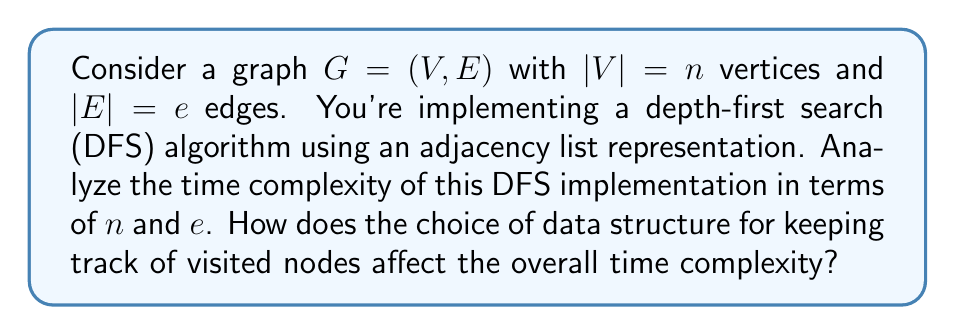Teach me how to tackle this problem. Let's break down the analysis step-by-step:

1. Initialization:
   - Creating an adjacency list: $O(n + e)$
   - Initializing a data structure to keep track of visited nodes: $O(n)$

2. DFS traversal:
   - Each vertex is processed once: $O(n)$
   - For each vertex, we iterate through its adjacent vertices:
     $$\sum_{v \in V} \text{degree}(v) = 2e$$
     This sum is $2e$ because each edge contributes to the degree of two vertices.

3. Visiting a node:
   The time complexity of marking a node as visited depends on the data structure used:
   - Array: $O(1)$
   - Hash set: $O(1)$ average case, $O(n)$ worst case
   - Bit vector: $O(1)$

4. Total time complexity:
   $$T(n, e) = O(n + e) + O(n) + O(n) + O(2e) * O(1) = O(n + e)$$

The choice of data structure for keeping track of visited nodes doesn't significantly affect the overall time complexity in this case. Even if we use a hash set with $O(n)$ worst-case lookup time, the total complexity remains $O(n + e)$ because:

$$O(n + e) + O(n) + O(n) + O(2e) * O(n) = O(n + e + n^2 + en) = O(n^2 + en)$$

However, since $e = O(n^2)$ in the worst case (for a complete graph), this simplifies to $O(n^2)$, which is still expressed as $O(n + e)$ in graph theory notation.

In practice, using an array or bit vector for visited nodes is more efficient and doesn't introduce any additional complexity.
Answer: The time complexity of depth-first search (DFS) on a graph with $n$ vertices and $e$ edges, implemented using an adjacency list, is $O(n + e)$. This complexity holds regardless of the choice of data structure for keeping track of visited nodes, assuming constant-time operations for marking nodes as visited. 